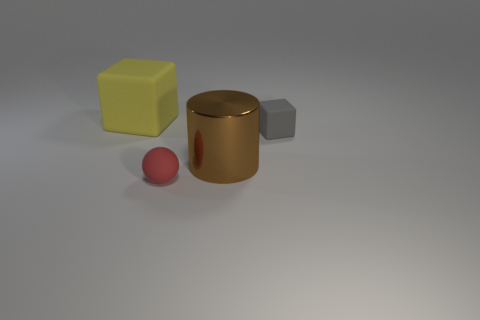Are there more tiny red rubber things that are on the right side of the red rubber thing than cylinders in front of the large cylinder?
Your answer should be compact. No. How many brown metal objects are the same size as the cylinder?
Make the answer very short. 0. Are there fewer big metal things on the left side of the red rubber sphere than things that are on the right side of the large yellow object?
Keep it short and to the point. Yes. Are there any tiny gray rubber things that have the same shape as the yellow rubber thing?
Provide a short and direct response. Yes. Do the large matte thing and the tiny red object have the same shape?
Make the answer very short. No. What number of tiny objects are either shiny objects or gray matte things?
Ensure brevity in your answer.  1. Is the number of brown metal objects greater than the number of big spheres?
Your answer should be compact. Yes. What size is the ball that is the same material as the gray cube?
Provide a succinct answer. Small. Does the rubber object in front of the metal object have the same size as the object behind the gray cube?
Provide a short and direct response. No. How many objects are tiny matte things behind the small red ball or small gray matte cubes?
Your response must be concise. 1. 